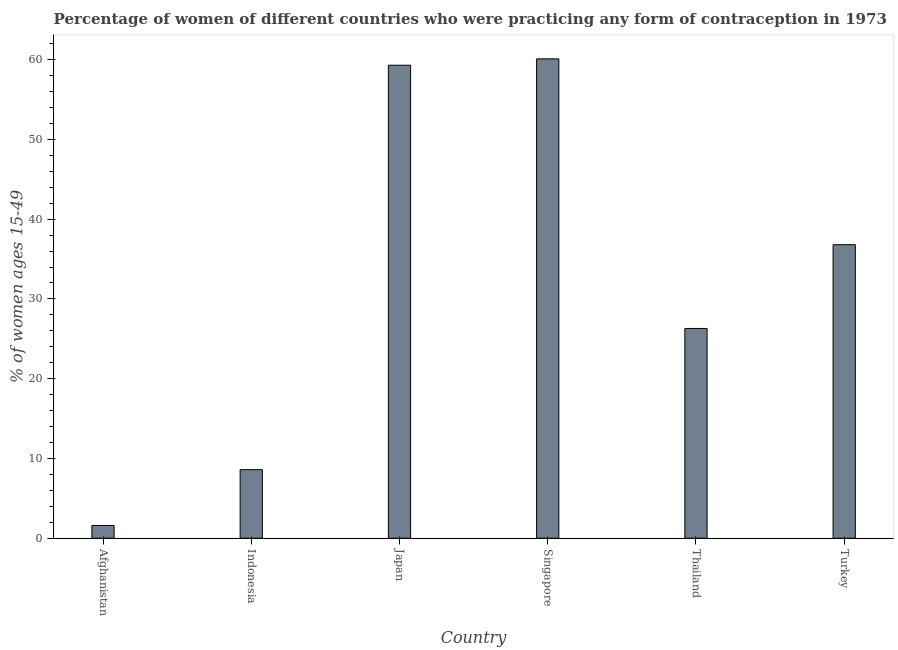Does the graph contain grids?
Keep it short and to the point. No. What is the title of the graph?
Your response must be concise. Percentage of women of different countries who were practicing any form of contraception in 1973. What is the label or title of the Y-axis?
Offer a terse response. % of women ages 15-49. What is the contraceptive prevalence in Singapore?
Keep it short and to the point. 60.1. Across all countries, what is the maximum contraceptive prevalence?
Keep it short and to the point. 60.1. Across all countries, what is the minimum contraceptive prevalence?
Your response must be concise. 1.6. In which country was the contraceptive prevalence maximum?
Your answer should be compact. Singapore. In which country was the contraceptive prevalence minimum?
Your response must be concise. Afghanistan. What is the sum of the contraceptive prevalence?
Your answer should be compact. 192.7. What is the difference between the contraceptive prevalence in Afghanistan and Singapore?
Offer a very short reply. -58.5. What is the average contraceptive prevalence per country?
Provide a short and direct response. 32.12. What is the median contraceptive prevalence?
Your response must be concise. 31.55. What is the ratio of the contraceptive prevalence in Indonesia to that in Japan?
Your response must be concise. 0.14. Is the contraceptive prevalence in Japan less than that in Turkey?
Ensure brevity in your answer.  No. Is the difference between the contraceptive prevalence in Japan and Thailand greater than the difference between any two countries?
Keep it short and to the point. No. What is the difference between the highest and the lowest contraceptive prevalence?
Give a very brief answer. 58.5. In how many countries, is the contraceptive prevalence greater than the average contraceptive prevalence taken over all countries?
Offer a very short reply. 3. Are all the bars in the graph horizontal?
Your response must be concise. No. How many countries are there in the graph?
Ensure brevity in your answer.  6. What is the difference between two consecutive major ticks on the Y-axis?
Keep it short and to the point. 10. Are the values on the major ticks of Y-axis written in scientific E-notation?
Ensure brevity in your answer.  No. What is the % of women ages 15-49 in Indonesia?
Give a very brief answer. 8.6. What is the % of women ages 15-49 of Japan?
Offer a very short reply. 59.3. What is the % of women ages 15-49 in Singapore?
Your answer should be very brief. 60.1. What is the % of women ages 15-49 in Thailand?
Your response must be concise. 26.3. What is the % of women ages 15-49 in Turkey?
Provide a short and direct response. 36.8. What is the difference between the % of women ages 15-49 in Afghanistan and Japan?
Your answer should be very brief. -57.7. What is the difference between the % of women ages 15-49 in Afghanistan and Singapore?
Offer a terse response. -58.5. What is the difference between the % of women ages 15-49 in Afghanistan and Thailand?
Keep it short and to the point. -24.7. What is the difference between the % of women ages 15-49 in Afghanistan and Turkey?
Offer a terse response. -35.2. What is the difference between the % of women ages 15-49 in Indonesia and Japan?
Offer a very short reply. -50.7. What is the difference between the % of women ages 15-49 in Indonesia and Singapore?
Your response must be concise. -51.5. What is the difference between the % of women ages 15-49 in Indonesia and Thailand?
Your response must be concise. -17.7. What is the difference between the % of women ages 15-49 in Indonesia and Turkey?
Your answer should be very brief. -28.2. What is the difference between the % of women ages 15-49 in Japan and Turkey?
Your answer should be compact. 22.5. What is the difference between the % of women ages 15-49 in Singapore and Thailand?
Keep it short and to the point. 33.8. What is the difference between the % of women ages 15-49 in Singapore and Turkey?
Provide a short and direct response. 23.3. What is the difference between the % of women ages 15-49 in Thailand and Turkey?
Provide a short and direct response. -10.5. What is the ratio of the % of women ages 15-49 in Afghanistan to that in Indonesia?
Give a very brief answer. 0.19. What is the ratio of the % of women ages 15-49 in Afghanistan to that in Japan?
Ensure brevity in your answer.  0.03. What is the ratio of the % of women ages 15-49 in Afghanistan to that in Singapore?
Give a very brief answer. 0.03. What is the ratio of the % of women ages 15-49 in Afghanistan to that in Thailand?
Offer a very short reply. 0.06. What is the ratio of the % of women ages 15-49 in Afghanistan to that in Turkey?
Provide a succinct answer. 0.04. What is the ratio of the % of women ages 15-49 in Indonesia to that in Japan?
Keep it short and to the point. 0.14. What is the ratio of the % of women ages 15-49 in Indonesia to that in Singapore?
Make the answer very short. 0.14. What is the ratio of the % of women ages 15-49 in Indonesia to that in Thailand?
Provide a succinct answer. 0.33. What is the ratio of the % of women ages 15-49 in Indonesia to that in Turkey?
Offer a terse response. 0.23. What is the ratio of the % of women ages 15-49 in Japan to that in Singapore?
Offer a very short reply. 0.99. What is the ratio of the % of women ages 15-49 in Japan to that in Thailand?
Make the answer very short. 2.25. What is the ratio of the % of women ages 15-49 in Japan to that in Turkey?
Your answer should be compact. 1.61. What is the ratio of the % of women ages 15-49 in Singapore to that in Thailand?
Offer a terse response. 2.29. What is the ratio of the % of women ages 15-49 in Singapore to that in Turkey?
Ensure brevity in your answer.  1.63. What is the ratio of the % of women ages 15-49 in Thailand to that in Turkey?
Offer a very short reply. 0.71. 